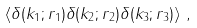<formula> <loc_0><loc_0><loc_500><loc_500>\left < \delta ( k _ { 1 } ; r _ { 1 } ) \delta ( k _ { 2 } ; r _ { 2 } ) \delta ( k _ { 3 } ; r _ { 3 } ) \right > \, ,</formula> 